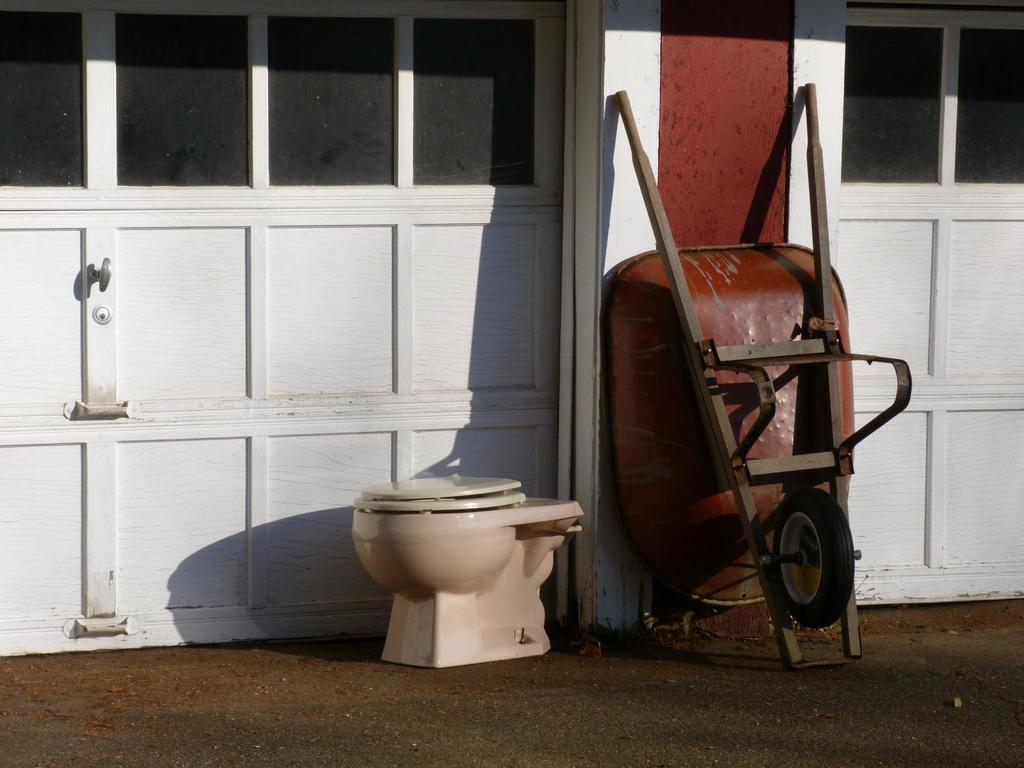What object is present in the image that is typically used for carrying items? There is a cart in the image. What object is present in the image that is typically used for personal hygiene? There is a toilet seat in the image. What type of structure is visible in the image? There is a wall in the image. What type of feature is present in the image that allows for privacy or access control? There are doors in the image. What type of calendar is hanging on the wall in the image? There is no calendar present in the image; only a cart, toilet seat, wall, and doors are visible. How does the toilet seat breathe in the image? Toilet seats do not breathe; they are inanimate objects. 